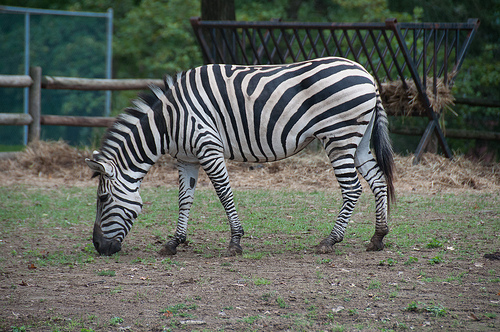Describe any signs of wear or peculiarities you notice on the zebra's body. Upon closer inspection, the zebra's stripes near its rear appear slightly smudged, which could indicate recent rolling in dirt or mud possibly to deter pests. Additionally, the hooves look somewhat worn, suggesting usual movement across rough terrain. How might these features affect the zebra's daily activities? The mud on its coat can help protect the zebra from insect bites, while the wear on its hooves is typical and shouldn't hinder its ability to traverse its environment. These adaptations are vital for its survival in the wild or in semi-wild habitats like a sanctuary. 